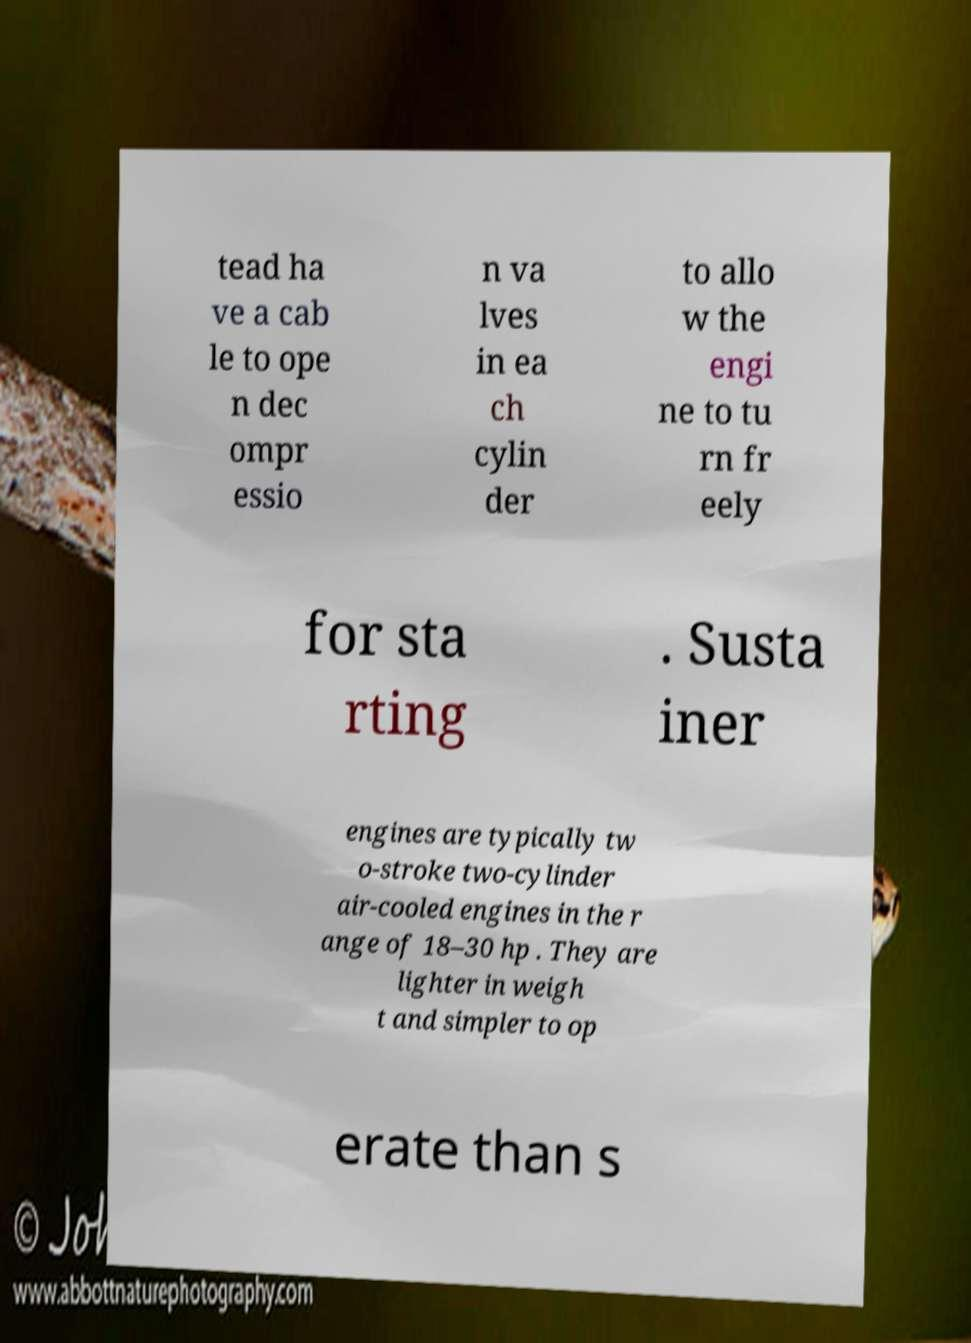I need the written content from this picture converted into text. Can you do that? tead ha ve a cab le to ope n dec ompr essio n va lves in ea ch cylin der to allo w the engi ne to tu rn fr eely for sta rting . Susta iner engines are typically tw o-stroke two-cylinder air-cooled engines in the r ange of 18–30 hp . They are lighter in weigh t and simpler to op erate than s 